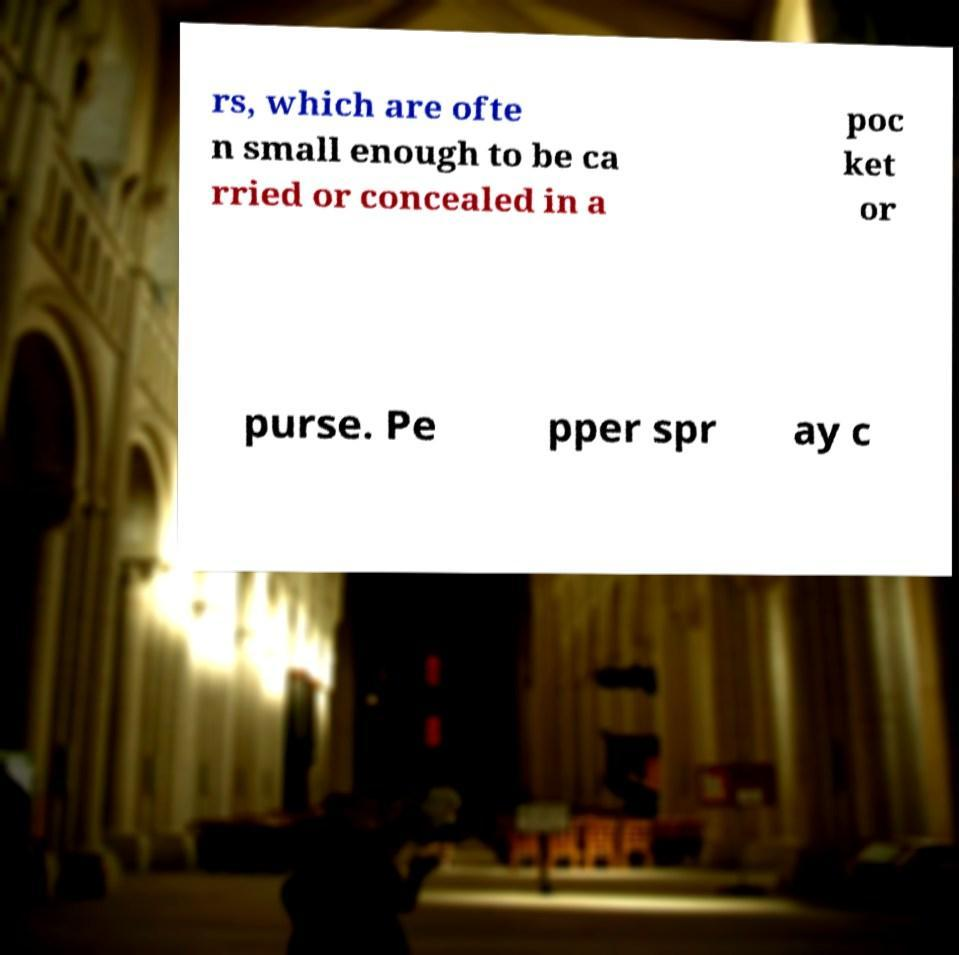What messages or text are displayed in this image? I need them in a readable, typed format. rs, which are ofte n small enough to be ca rried or concealed in a poc ket or purse. Pe pper spr ay c 